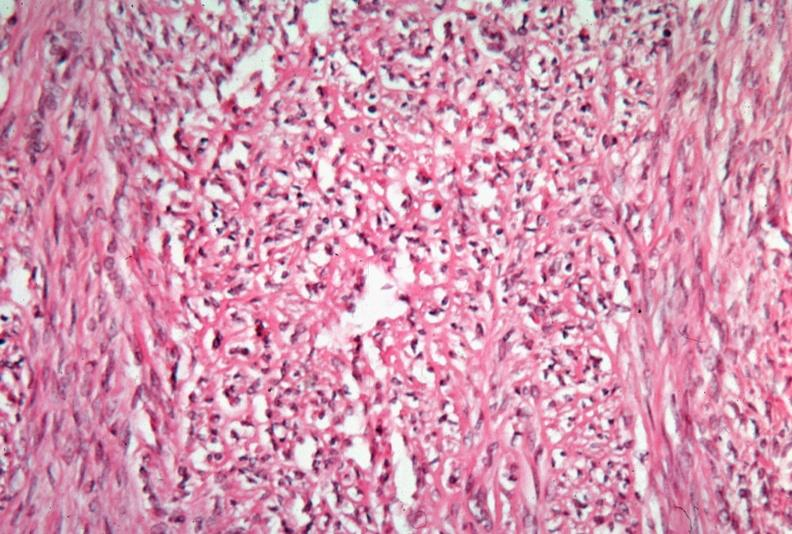does this image show uterus, leiomyoma?
Answer the question using a single word or phrase. Yes 